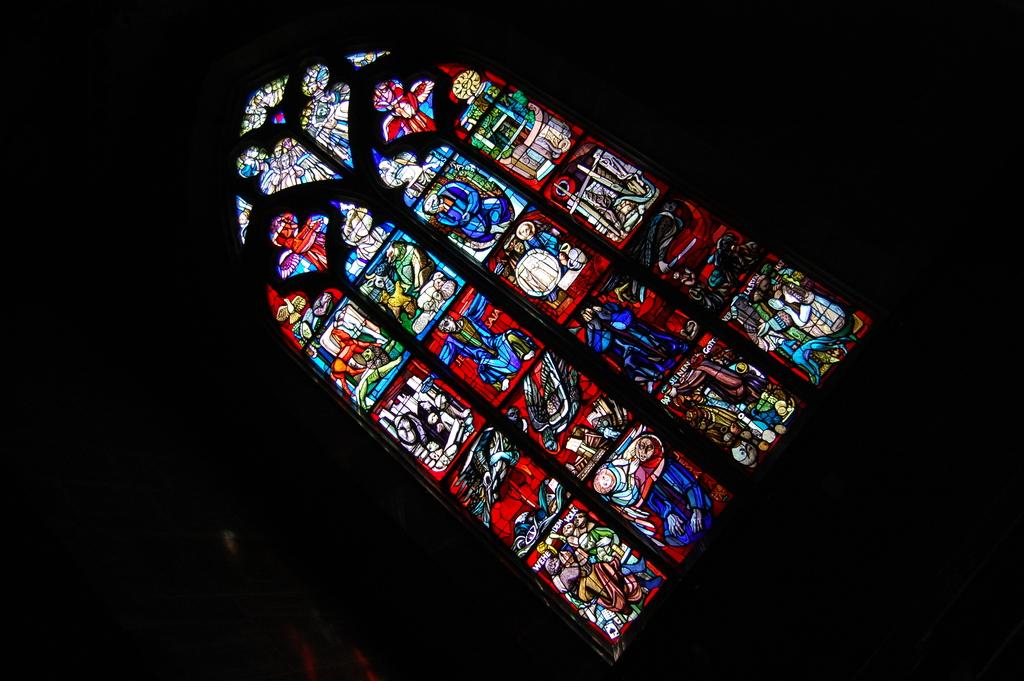What is the overall tone or appearance of the image? The picture is dark. What type of artwork is depicted in the image? There is a painting on glass in the image. Can you see any water or waves in the image? There is no water or waves present in the image; it features a painting on glass. Is there a gate visible in the image? There is no gate present in the image; it only features a painting on glass. 